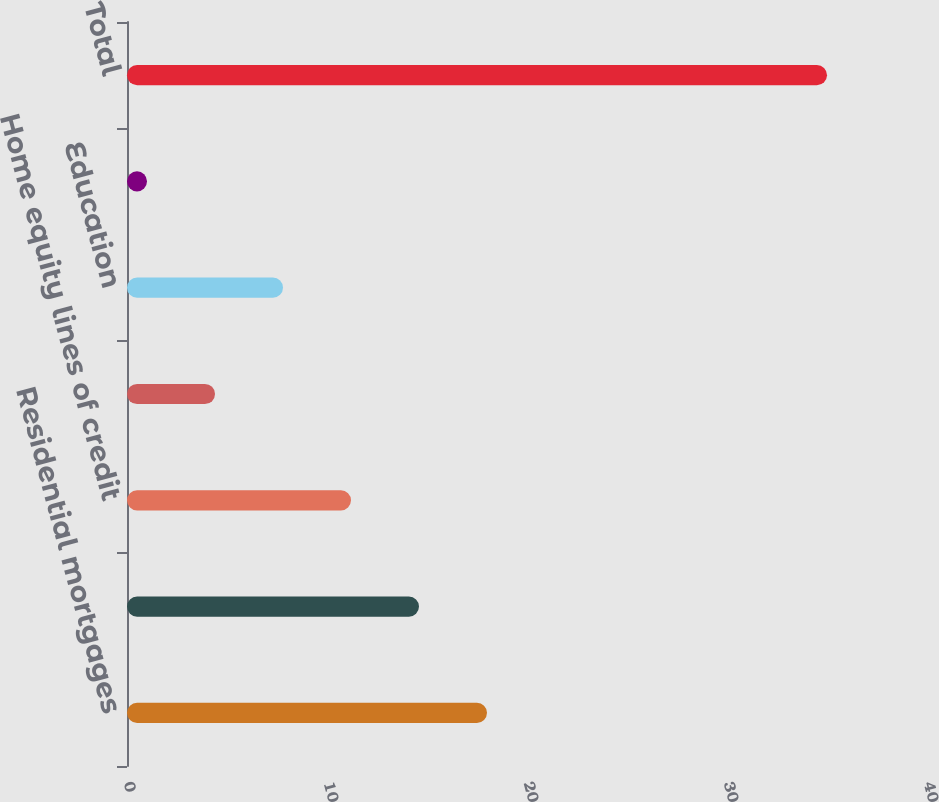Convert chart. <chart><loc_0><loc_0><loc_500><loc_500><bar_chart><fcel>Residential mortgages<fcel>Home equity loans<fcel>Home equity lines of credit<fcel>Home equity loans serviced by<fcel>Education<fcel>Credit cards<fcel>Total<nl><fcel>18<fcel>14.6<fcel>11.2<fcel>4.4<fcel>7.8<fcel>1<fcel>35<nl></chart> 